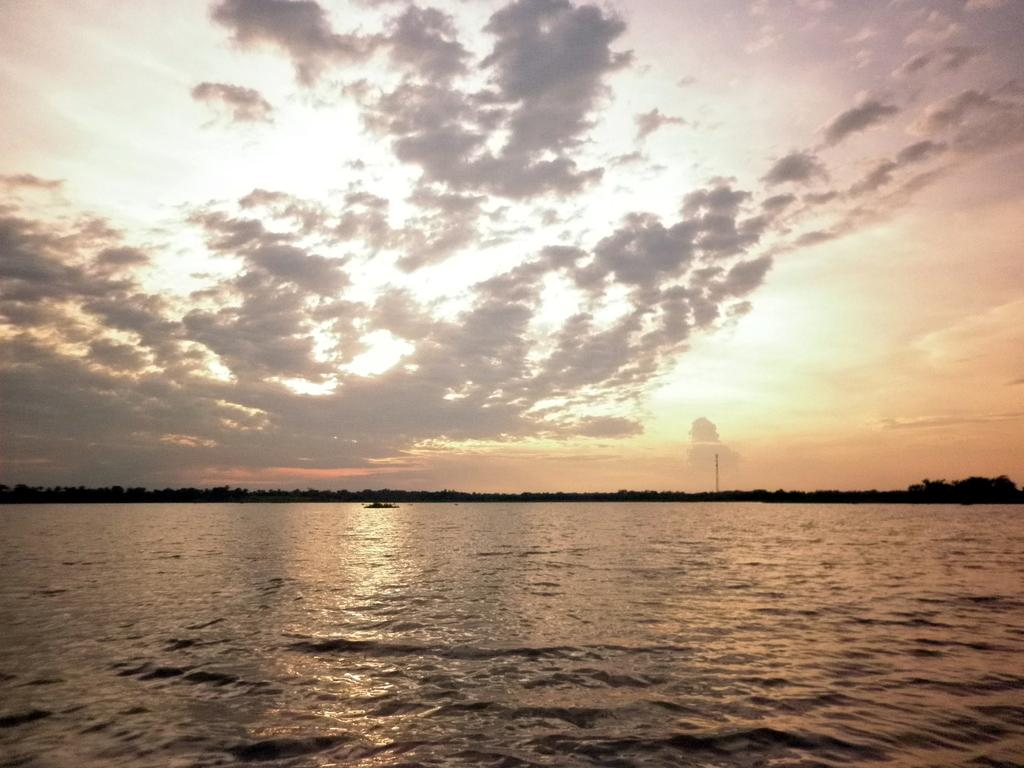What type of natural feature is at the bottom of the image? There is a river at the bottom of the image. What can be seen in the background of the image? There are many trees and a tower in the background of the image. What is visible at the top of the image? The sky is visible at the top of the image. What can be observed in the sky? Clouds are present in the sky. What type of insurance policy is being discussed by the goldfish in the image? There are no goldfish present in the image, and therefore no discussion about insurance policies can be observed. How many apples are visible in the image? There are no apples present in the image. 